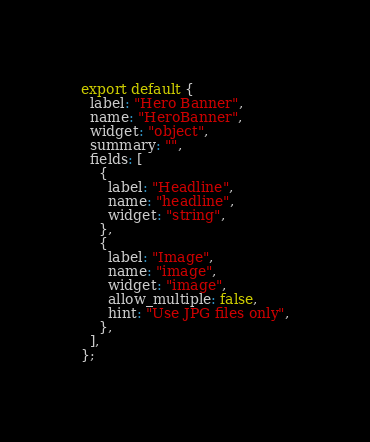Convert code to text. <code><loc_0><loc_0><loc_500><loc_500><_JavaScript_>export default {
  label: "Hero Banner",
  name: "HeroBanner",
  widget: "object",
  summary: "",
  fields: [
    {
      label: "Headline",
      name: "headline",
      widget: "string",
    },
    {
      label: "Image",
      name: "image",
      widget: "image",
      allow_multiple: false,
      hint: "Use JPG files only",
    },
  ],
};
</code> 